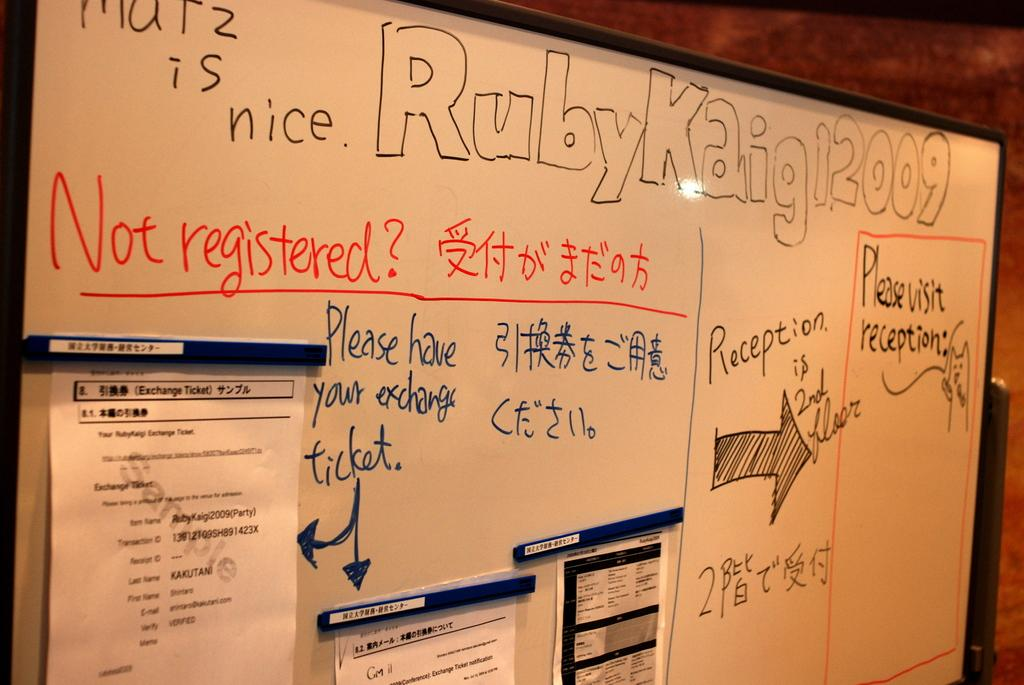<image>
Relay a brief, clear account of the picture shown. A whiteboard has information pertaining to Ruby Kaigi 2009 written on it. 